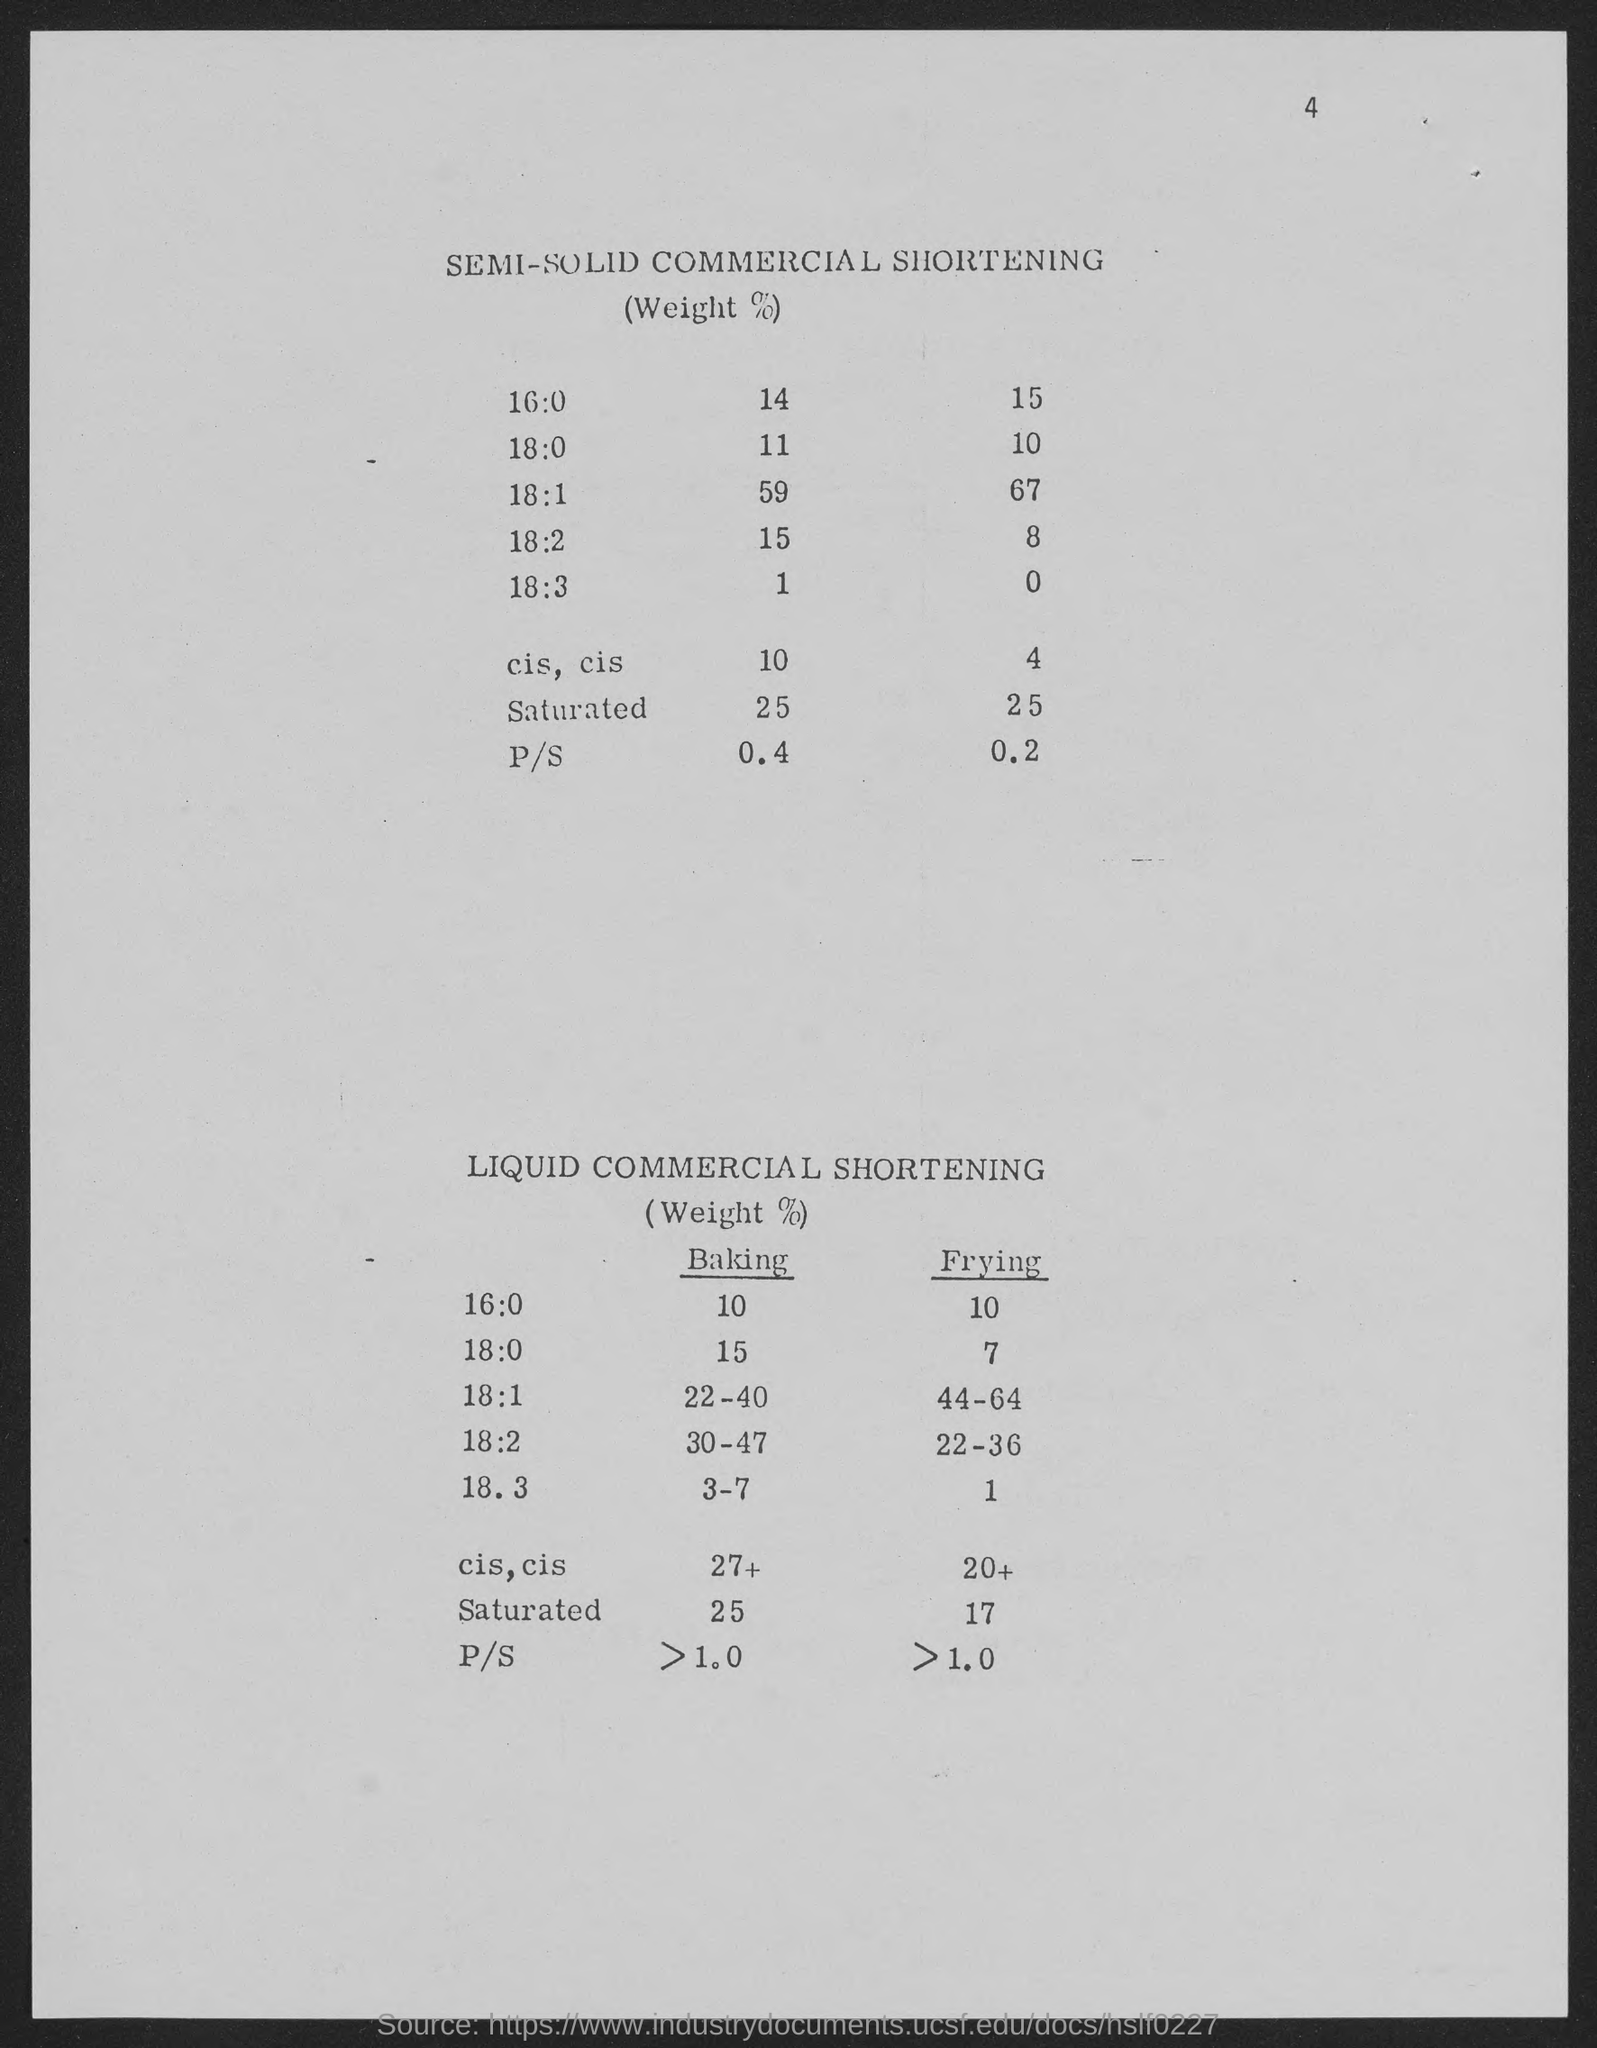Mention a couple of crucial points in this snapshot. The number located in the top-right corner of the page is 4. 